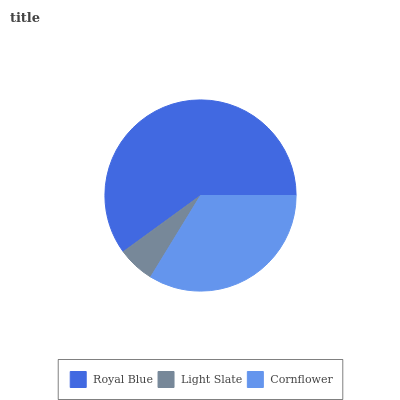Is Light Slate the minimum?
Answer yes or no. Yes. Is Royal Blue the maximum?
Answer yes or no. Yes. Is Cornflower the minimum?
Answer yes or no. No. Is Cornflower the maximum?
Answer yes or no. No. Is Cornflower greater than Light Slate?
Answer yes or no. Yes. Is Light Slate less than Cornflower?
Answer yes or no. Yes. Is Light Slate greater than Cornflower?
Answer yes or no. No. Is Cornflower less than Light Slate?
Answer yes or no. No. Is Cornflower the high median?
Answer yes or no. Yes. Is Cornflower the low median?
Answer yes or no. Yes. Is Light Slate the high median?
Answer yes or no. No. Is Royal Blue the low median?
Answer yes or no. No. 